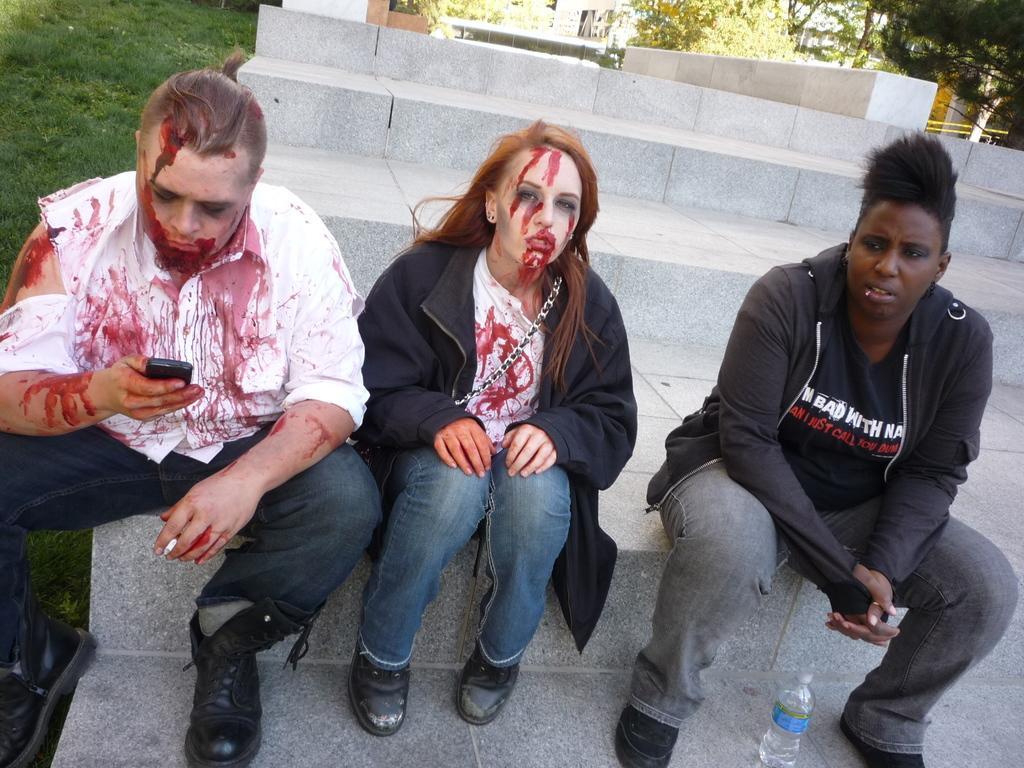Can you describe this image briefly? In this picture we can see three people sitting on the step and one person is holding a mobile, in front of them we can see a bottle and in the background we can see few steps, grass, trees and few objects. 